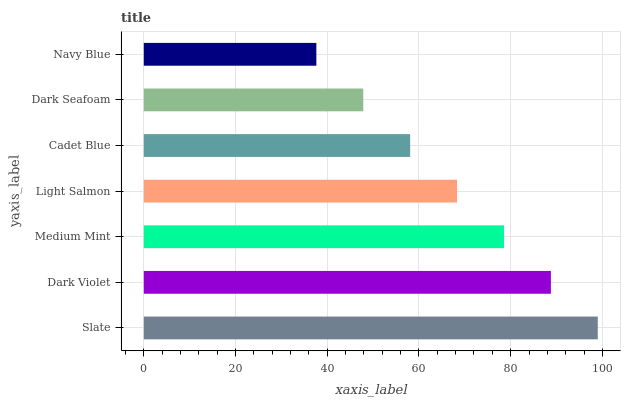Is Navy Blue the minimum?
Answer yes or no. Yes. Is Slate the maximum?
Answer yes or no. Yes. Is Dark Violet the minimum?
Answer yes or no. No. Is Dark Violet the maximum?
Answer yes or no. No. Is Slate greater than Dark Violet?
Answer yes or no. Yes. Is Dark Violet less than Slate?
Answer yes or no. Yes. Is Dark Violet greater than Slate?
Answer yes or no. No. Is Slate less than Dark Violet?
Answer yes or no. No. Is Light Salmon the high median?
Answer yes or no. Yes. Is Light Salmon the low median?
Answer yes or no. Yes. Is Medium Mint the high median?
Answer yes or no. No. Is Cadet Blue the low median?
Answer yes or no. No. 